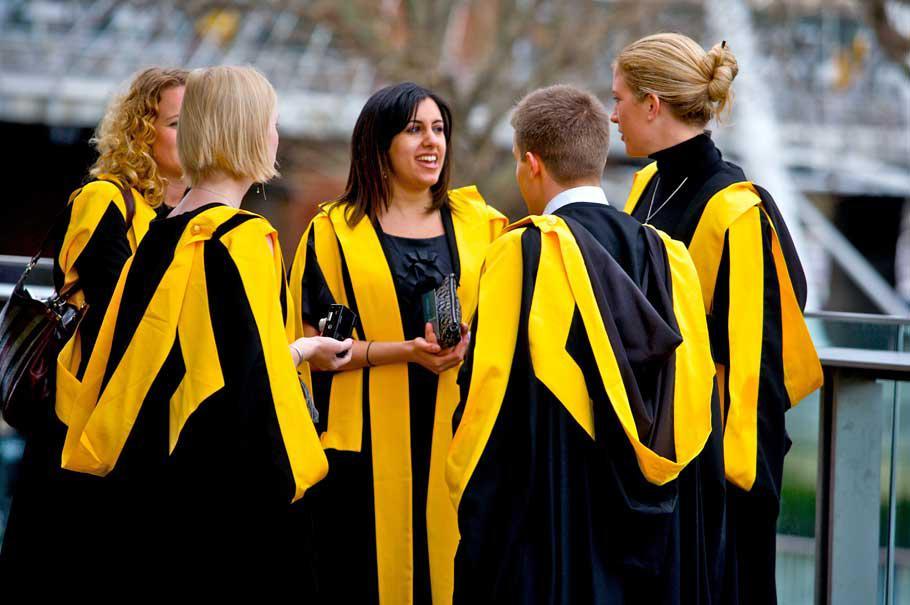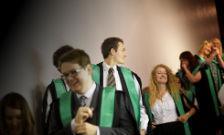The first image is the image on the left, the second image is the image on the right. Assess this claim about the two images: "At least three people are wearing yellow graduation stoles in the image on the left.". Correct or not? Answer yes or no. Yes. The first image is the image on the left, the second image is the image on the right. Examine the images to the left and right. Is the description "Multiple young women in black and yellow stand in the foreground of an image." accurate? Answer yes or no. Yes. 